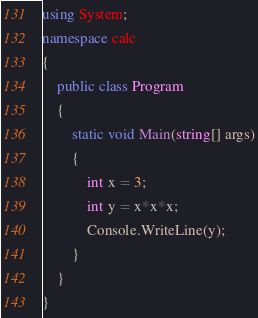Convert code to text. <code><loc_0><loc_0><loc_500><loc_500><_C#_>using System;
namespace calc
{
    public class Program
    {
        static void Main(string[] args)
        {
            int x = 3;
            int y = x*x*x;
            Console.WriteLine(y);
        }
    }
}
</code> 